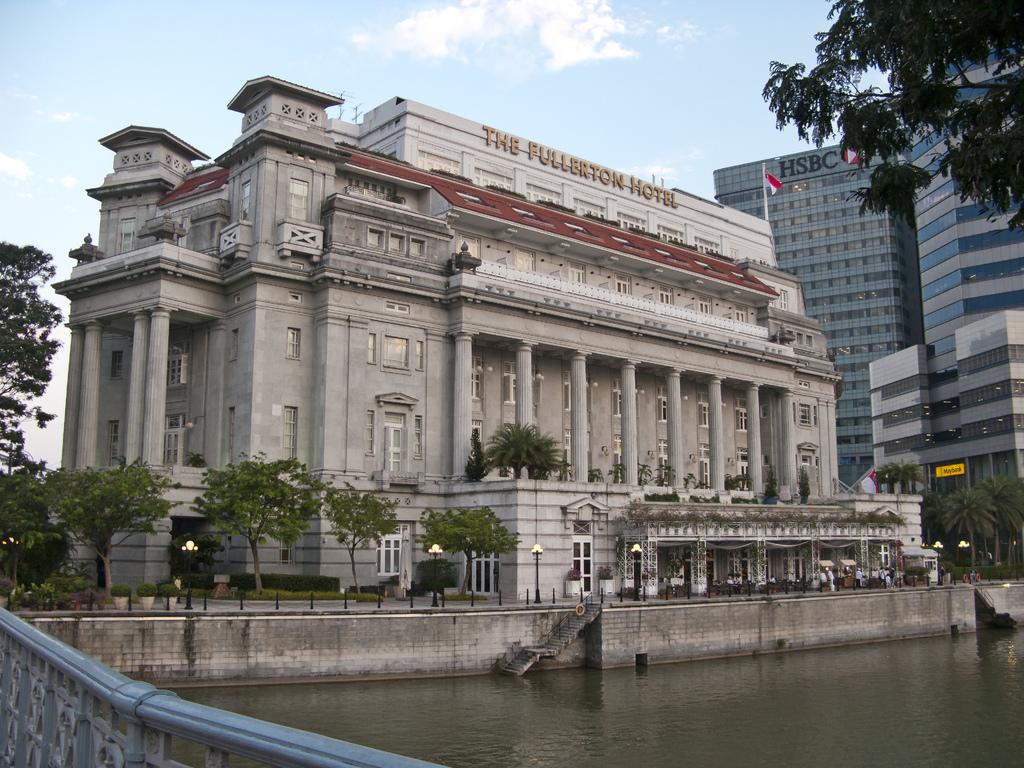What type of structures can be seen in the image? There are buildings in the image. What natural elements are present in the image? There are trees in the image. What architectural feature is visible in the image? There are stairs in the image. What type of lighting is present in the image? There are lights in the image. What material is used for the poles in the image? There are iron poles in the image. What is attached to one of the poles in the image? There is a pole with a flag in the image. What type of liquid is visible in the image? There is water visible in the image. What type of barrier is present in the image? There is fencing in the image. What can be seen in the background of the image? The sky is visible in the background of the image. How many bikes are parked near the buildings in the image? There are no bikes present in the image. 